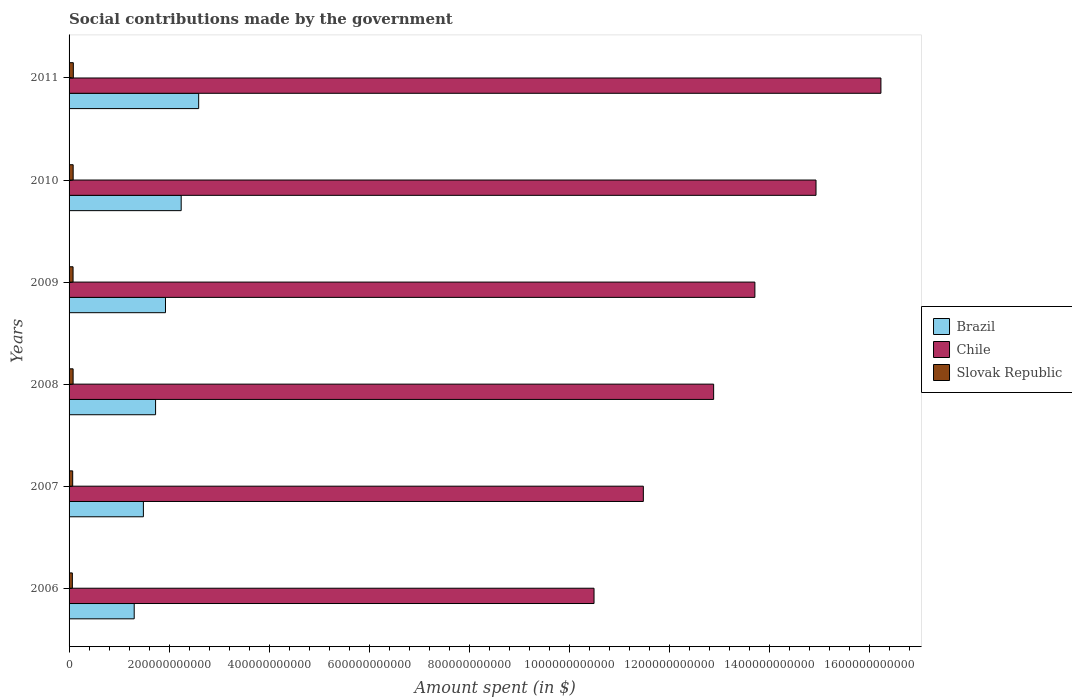How many different coloured bars are there?
Give a very brief answer. 3. Are the number of bars on each tick of the Y-axis equal?
Your answer should be very brief. Yes. How many bars are there on the 2nd tick from the top?
Give a very brief answer. 3. How many bars are there on the 4th tick from the bottom?
Provide a succinct answer. 3. What is the label of the 3rd group of bars from the top?
Keep it short and to the point. 2009. In how many cases, is the number of bars for a given year not equal to the number of legend labels?
Keep it short and to the point. 0. What is the amount spent on social contributions in Slovak Republic in 2008?
Your answer should be compact. 8.07e+09. Across all years, what is the maximum amount spent on social contributions in Slovak Republic?
Provide a succinct answer. 8.51e+09. Across all years, what is the minimum amount spent on social contributions in Chile?
Your answer should be compact. 1.05e+12. In which year was the amount spent on social contributions in Slovak Republic maximum?
Offer a very short reply. 2011. What is the total amount spent on social contributions in Chile in the graph?
Your answer should be compact. 7.98e+12. What is the difference between the amount spent on social contributions in Slovak Republic in 2006 and that in 2007?
Ensure brevity in your answer.  -6.41e+08. What is the difference between the amount spent on social contributions in Slovak Republic in 2006 and the amount spent on social contributions in Chile in 2009?
Keep it short and to the point. -1.37e+12. What is the average amount spent on social contributions in Chile per year?
Provide a succinct answer. 1.33e+12. In the year 2006, what is the difference between the amount spent on social contributions in Brazil and amount spent on social contributions in Slovak Republic?
Keep it short and to the point. 1.24e+11. In how many years, is the amount spent on social contributions in Chile greater than 480000000000 $?
Your answer should be compact. 6. What is the ratio of the amount spent on social contributions in Chile in 2006 to that in 2009?
Your response must be concise. 0.77. Is the amount spent on social contributions in Chile in 2006 less than that in 2011?
Provide a succinct answer. Yes. Is the difference between the amount spent on social contributions in Brazil in 2007 and 2008 greater than the difference between the amount spent on social contributions in Slovak Republic in 2007 and 2008?
Provide a succinct answer. No. What is the difference between the highest and the second highest amount spent on social contributions in Slovak Republic?
Ensure brevity in your answer.  3.31e+08. What is the difference between the highest and the lowest amount spent on social contributions in Slovak Republic?
Provide a short and direct response. 1.93e+09. What does the 1st bar from the top in 2007 represents?
Your response must be concise. Slovak Republic. What does the 1st bar from the bottom in 2009 represents?
Provide a short and direct response. Brazil. What is the difference between two consecutive major ticks on the X-axis?
Provide a succinct answer. 2.00e+11. Does the graph contain any zero values?
Your answer should be compact. No. Where does the legend appear in the graph?
Give a very brief answer. Center right. What is the title of the graph?
Ensure brevity in your answer.  Social contributions made by the government. Does "Pacific island small states" appear as one of the legend labels in the graph?
Your answer should be compact. No. What is the label or title of the X-axis?
Provide a succinct answer. Amount spent (in $). What is the Amount spent (in $) in Brazil in 2006?
Ensure brevity in your answer.  1.30e+11. What is the Amount spent (in $) in Chile in 2006?
Provide a succinct answer. 1.05e+12. What is the Amount spent (in $) of Slovak Republic in 2006?
Ensure brevity in your answer.  6.59e+09. What is the Amount spent (in $) of Brazil in 2007?
Ensure brevity in your answer.  1.49e+11. What is the Amount spent (in $) of Chile in 2007?
Provide a short and direct response. 1.15e+12. What is the Amount spent (in $) in Slovak Republic in 2007?
Make the answer very short. 7.23e+09. What is the Amount spent (in $) in Brazil in 2008?
Offer a very short reply. 1.73e+11. What is the Amount spent (in $) in Chile in 2008?
Your answer should be very brief. 1.29e+12. What is the Amount spent (in $) of Slovak Republic in 2008?
Keep it short and to the point. 8.07e+09. What is the Amount spent (in $) of Brazil in 2009?
Offer a very short reply. 1.93e+11. What is the Amount spent (in $) in Chile in 2009?
Make the answer very short. 1.37e+12. What is the Amount spent (in $) of Slovak Republic in 2009?
Provide a succinct answer. 7.99e+09. What is the Amount spent (in $) of Brazil in 2010?
Make the answer very short. 2.24e+11. What is the Amount spent (in $) in Chile in 2010?
Give a very brief answer. 1.49e+12. What is the Amount spent (in $) in Slovak Republic in 2010?
Provide a short and direct response. 8.18e+09. What is the Amount spent (in $) of Brazil in 2011?
Your answer should be very brief. 2.59e+11. What is the Amount spent (in $) of Chile in 2011?
Provide a short and direct response. 1.62e+12. What is the Amount spent (in $) in Slovak Republic in 2011?
Your response must be concise. 8.51e+09. Across all years, what is the maximum Amount spent (in $) of Brazil?
Offer a terse response. 2.59e+11. Across all years, what is the maximum Amount spent (in $) of Chile?
Keep it short and to the point. 1.62e+12. Across all years, what is the maximum Amount spent (in $) in Slovak Republic?
Give a very brief answer. 8.51e+09. Across all years, what is the minimum Amount spent (in $) of Brazil?
Give a very brief answer. 1.30e+11. Across all years, what is the minimum Amount spent (in $) in Chile?
Your answer should be very brief. 1.05e+12. Across all years, what is the minimum Amount spent (in $) of Slovak Republic?
Your answer should be very brief. 6.59e+09. What is the total Amount spent (in $) in Brazil in the graph?
Provide a succinct answer. 1.13e+12. What is the total Amount spent (in $) in Chile in the graph?
Your response must be concise. 7.98e+12. What is the total Amount spent (in $) of Slovak Republic in the graph?
Your response must be concise. 4.66e+1. What is the difference between the Amount spent (in $) of Brazil in 2006 and that in 2007?
Keep it short and to the point. -1.84e+1. What is the difference between the Amount spent (in $) of Chile in 2006 and that in 2007?
Offer a terse response. -9.86e+1. What is the difference between the Amount spent (in $) of Slovak Republic in 2006 and that in 2007?
Provide a short and direct response. -6.41e+08. What is the difference between the Amount spent (in $) of Brazil in 2006 and that in 2008?
Offer a terse response. -4.28e+1. What is the difference between the Amount spent (in $) in Chile in 2006 and that in 2008?
Keep it short and to the point. -2.39e+11. What is the difference between the Amount spent (in $) in Slovak Republic in 2006 and that in 2008?
Give a very brief answer. -1.48e+09. What is the difference between the Amount spent (in $) in Brazil in 2006 and that in 2009?
Offer a terse response. -6.26e+1. What is the difference between the Amount spent (in $) in Chile in 2006 and that in 2009?
Give a very brief answer. -3.22e+11. What is the difference between the Amount spent (in $) of Slovak Republic in 2006 and that in 2009?
Make the answer very short. -1.41e+09. What is the difference between the Amount spent (in $) of Brazil in 2006 and that in 2010?
Offer a terse response. -9.40e+1. What is the difference between the Amount spent (in $) in Chile in 2006 and that in 2010?
Your response must be concise. -4.44e+11. What is the difference between the Amount spent (in $) of Slovak Republic in 2006 and that in 2010?
Your response must be concise. -1.60e+09. What is the difference between the Amount spent (in $) in Brazil in 2006 and that in 2011?
Make the answer very short. -1.29e+11. What is the difference between the Amount spent (in $) of Chile in 2006 and that in 2011?
Make the answer very short. -5.74e+11. What is the difference between the Amount spent (in $) in Slovak Republic in 2006 and that in 2011?
Ensure brevity in your answer.  -1.93e+09. What is the difference between the Amount spent (in $) of Brazil in 2007 and that in 2008?
Provide a short and direct response. -2.44e+1. What is the difference between the Amount spent (in $) of Chile in 2007 and that in 2008?
Give a very brief answer. -1.41e+11. What is the difference between the Amount spent (in $) in Slovak Republic in 2007 and that in 2008?
Provide a short and direct response. -8.43e+08. What is the difference between the Amount spent (in $) of Brazil in 2007 and that in 2009?
Provide a succinct answer. -4.42e+1. What is the difference between the Amount spent (in $) in Chile in 2007 and that in 2009?
Ensure brevity in your answer.  -2.23e+11. What is the difference between the Amount spent (in $) in Slovak Republic in 2007 and that in 2009?
Your response must be concise. -7.65e+08. What is the difference between the Amount spent (in $) in Brazil in 2007 and that in 2010?
Ensure brevity in your answer.  -7.56e+1. What is the difference between the Amount spent (in $) of Chile in 2007 and that in 2010?
Offer a very short reply. -3.45e+11. What is the difference between the Amount spent (in $) in Slovak Republic in 2007 and that in 2010?
Ensure brevity in your answer.  -9.55e+08. What is the difference between the Amount spent (in $) of Brazil in 2007 and that in 2011?
Provide a short and direct response. -1.11e+11. What is the difference between the Amount spent (in $) of Chile in 2007 and that in 2011?
Give a very brief answer. -4.75e+11. What is the difference between the Amount spent (in $) of Slovak Republic in 2007 and that in 2011?
Your answer should be very brief. -1.29e+09. What is the difference between the Amount spent (in $) in Brazil in 2008 and that in 2009?
Offer a terse response. -1.98e+1. What is the difference between the Amount spent (in $) in Chile in 2008 and that in 2009?
Offer a terse response. -8.25e+1. What is the difference between the Amount spent (in $) of Slovak Republic in 2008 and that in 2009?
Provide a succinct answer. 7.78e+07. What is the difference between the Amount spent (in $) in Brazil in 2008 and that in 2010?
Keep it short and to the point. -5.12e+1. What is the difference between the Amount spent (in $) of Chile in 2008 and that in 2010?
Ensure brevity in your answer.  -2.05e+11. What is the difference between the Amount spent (in $) of Slovak Republic in 2008 and that in 2010?
Provide a succinct answer. -1.13e+08. What is the difference between the Amount spent (in $) in Brazil in 2008 and that in 2011?
Keep it short and to the point. -8.62e+1. What is the difference between the Amount spent (in $) in Chile in 2008 and that in 2011?
Provide a short and direct response. -3.35e+11. What is the difference between the Amount spent (in $) in Slovak Republic in 2008 and that in 2011?
Keep it short and to the point. -4.43e+08. What is the difference between the Amount spent (in $) in Brazil in 2009 and that in 2010?
Give a very brief answer. -3.14e+1. What is the difference between the Amount spent (in $) of Chile in 2009 and that in 2010?
Make the answer very short. -1.22e+11. What is the difference between the Amount spent (in $) of Slovak Republic in 2009 and that in 2010?
Your answer should be compact. -1.91e+08. What is the difference between the Amount spent (in $) of Brazil in 2009 and that in 2011?
Your response must be concise. -6.64e+1. What is the difference between the Amount spent (in $) in Chile in 2009 and that in 2011?
Your answer should be compact. -2.52e+11. What is the difference between the Amount spent (in $) of Slovak Republic in 2009 and that in 2011?
Your answer should be compact. -5.21e+08. What is the difference between the Amount spent (in $) of Brazil in 2010 and that in 2011?
Your answer should be very brief. -3.50e+1. What is the difference between the Amount spent (in $) in Chile in 2010 and that in 2011?
Make the answer very short. -1.30e+11. What is the difference between the Amount spent (in $) in Slovak Republic in 2010 and that in 2011?
Give a very brief answer. -3.31e+08. What is the difference between the Amount spent (in $) in Brazil in 2006 and the Amount spent (in $) in Chile in 2007?
Ensure brevity in your answer.  -1.02e+12. What is the difference between the Amount spent (in $) in Brazil in 2006 and the Amount spent (in $) in Slovak Republic in 2007?
Provide a short and direct response. 1.23e+11. What is the difference between the Amount spent (in $) in Chile in 2006 and the Amount spent (in $) in Slovak Republic in 2007?
Your answer should be very brief. 1.04e+12. What is the difference between the Amount spent (in $) of Brazil in 2006 and the Amount spent (in $) of Chile in 2008?
Your answer should be compact. -1.16e+12. What is the difference between the Amount spent (in $) of Brazil in 2006 and the Amount spent (in $) of Slovak Republic in 2008?
Offer a very short reply. 1.22e+11. What is the difference between the Amount spent (in $) in Chile in 2006 and the Amount spent (in $) in Slovak Republic in 2008?
Provide a succinct answer. 1.04e+12. What is the difference between the Amount spent (in $) of Brazil in 2006 and the Amount spent (in $) of Chile in 2009?
Give a very brief answer. -1.24e+12. What is the difference between the Amount spent (in $) of Brazil in 2006 and the Amount spent (in $) of Slovak Republic in 2009?
Give a very brief answer. 1.22e+11. What is the difference between the Amount spent (in $) in Chile in 2006 and the Amount spent (in $) in Slovak Republic in 2009?
Ensure brevity in your answer.  1.04e+12. What is the difference between the Amount spent (in $) in Brazil in 2006 and the Amount spent (in $) in Chile in 2010?
Provide a succinct answer. -1.36e+12. What is the difference between the Amount spent (in $) of Brazil in 2006 and the Amount spent (in $) of Slovak Republic in 2010?
Provide a succinct answer. 1.22e+11. What is the difference between the Amount spent (in $) of Chile in 2006 and the Amount spent (in $) of Slovak Republic in 2010?
Offer a very short reply. 1.04e+12. What is the difference between the Amount spent (in $) in Brazil in 2006 and the Amount spent (in $) in Chile in 2011?
Keep it short and to the point. -1.49e+12. What is the difference between the Amount spent (in $) in Brazil in 2006 and the Amount spent (in $) in Slovak Republic in 2011?
Give a very brief answer. 1.22e+11. What is the difference between the Amount spent (in $) in Chile in 2006 and the Amount spent (in $) in Slovak Republic in 2011?
Your response must be concise. 1.04e+12. What is the difference between the Amount spent (in $) in Brazil in 2007 and the Amount spent (in $) in Chile in 2008?
Offer a terse response. -1.14e+12. What is the difference between the Amount spent (in $) of Brazil in 2007 and the Amount spent (in $) of Slovak Republic in 2008?
Your response must be concise. 1.41e+11. What is the difference between the Amount spent (in $) of Chile in 2007 and the Amount spent (in $) of Slovak Republic in 2008?
Provide a succinct answer. 1.14e+12. What is the difference between the Amount spent (in $) in Brazil in 2007 and the Amount spent (in $) in Chile in 2009?
Your answer should be compact. -1.22e+12. What is the difference between the Amount spent (in $) in Brazil in 2007 and the Amount spent (in $) in Slovak Republic in 2009?
Give a very brief answer. 1.41e+11. What is the difference between the Amount spent (in $) in Chile in 2007 and the Amount spent (in $) in Slovak Republic in 2009?
Make the answer very short. 1.14e+12. What is the difference between the Amount spent (in $) in Brazil in 2007 and the Amount spent (in $) in Chile in 2010?
Your answer should be compact. -1.35e+12. What is the difference between the Amount spent (in $) in Brazil in 2007 and the Amount spent (in $) in Slovak Republic in 2010?
Offer a very short reply. 1.40e+11. What is the difference between the Amount spent (in $) of Chile in 2007 and the Amount spent (in $) of Slovak Republic in 2010?
Keep it short and to the point. 1.14e+12. What is the difference between the Amount spent (in $) of Brazil in 2007 and the Amount spent (in $) of Chile in 2011?
Provide a succinct answer. -1.48e+12. What is the difference between the Amount spent (in $) in Brazil in 2007 and the Amount spent (in $) in Slovak Republic in 2011?
Ensure brevity in your answer.  1.40e+11. What is the difference between the Amount spent (in $) in Chile in 2007 and the Amount spent (in $) in Slovak Republic in 2011?
Offer a terse response. 1.14e+12. What is the difference between the Amount spent (in $) in Brazil in 2008 and the Amount spent (in $) in Chile in 2009?
Make the answer very short. -1.20e+12. What is the difference between the Amount spent (in $) in Brazil in 2008 and the Amount spent (in $) in Slovak Republic in 2009?
Provide a succinct answer. 1.65e+11. What is the difference between the Amount spent (in $) of Chile in 2008 and the Amount spent (in $) of Slovak Republic in 2009?
Your answer should be very brief. 1.28e+12. What is the difference between the Amount spent (in $) of Brazil in 2008 and the Amount spent (in $) of Chile in 2010?
Offer a very short reply. -1.32e+12. What is the difference between the Amount spent (in $) in Brazil in 2008 and the Amount spent (in $) in Slovak Republic in 2010?
Keep it short and to the point. 1.65e+11. What is the difference between the Amount spent (in $) in Chile in 2008 and the Amount spent (in $) in Slovak Republic in 2010?
Your response must be concise. 1.28e+12. What is the difference between the Amount spent (in $) in Brazil in 2008 and the Amount spent (in $) in Chile in 2011?
Offer a terse response. -1.45e+12. What is the difference between the Amount spent (in $) in Brazil in 2008 and the Amount spent (in $) in Slovak Republic in 2011?
Your response must be concise. 1.65e+11. What is the difference between the Amount spent (in $) in Chile in 2008 and the Amount spent (in $) in Slovak Republic in 2011?
Your response must be concise. 1.28e+12. What is the difference between the Amount spent (in $) of Brazil in 2009 and the Amount spent (in $) of Chile in 2010?
Offer a terse response. -1.30e+12. What is the difference between the Amount spent (in $) of Brazil in 2009 and the Amount spent (in $) of Slovak Republic in 2010?
Offer a terse response. 1.85e+11. What is the difference between the Amount spent (in $) of Chile in 2009 and the Amount spent (in $) of Slovak Republic in 2010?
Keep it short and to the point. 1.36e+12. What is the difference between the Amount spent (in $) of Brazil in 2009 and the Amount spent (in $) of Chile in 2011?
Offer a terse response. -1.43e+12. What is the difference between the Amount spent (in $) of Brazil in 2009 and the Amount spent (in $) of Slovak Republic in 2011?
Give a very brief answer. 1.84e+11. What is the difference between the Amount spent (in $) of Chile in 2009 and the Amount spent (in $) of Slovak Republic in 2011?
Your response must be concise. 1.36e+12. What is the difference between the Amount spent (in $) of Brazil in 2010 and the Amount spent (in $) of Chile in 2011?
Your response must be concise. -1.40e+12. What is the difference between the Amount spent (in $) in Brazil in 2010 and the Amount spent (in $) in Slovak Republic in 2011?
Your answer should be very brief. 2.16e+11. What is the difference between the Amount spent (in $) in Chile in 2010 and the Amount spent (in $) in Slovak Republic in 2011?
Give a very brief answer. 1.49e+12. What is the average Amount spent (in $) in Brazil per year?
Make the answer very short. 1.88e+11. What is the average Amount spent (in $) of Chile per year?
Your answer should be compact. 1.33e+12. What is the average Amount spent (in $) in Slovak Republic per year?
Make the answer very short. 7.76e+09. In the year 2006, what is the difference between the Amount spent (in $) in Brazil and Amount spent (in $) in Chile?
Make the answer very short. -9.20e+11. In the year 2006, what is the difference between the Amount spent (in $) of Brazil and Amount spent (in $) of Slovak Republic?
Make the answer very short. 1.24e+11. In the year 2006, what is the difference between the Amount spent (in $) of Chile and Amount spent (in $) of Slovak Republic?
Offer a terse response. 1.04e+12. In the year 2007, what is the difference between the Amount spent (in $) in Brazil and Amount spent (in $) in Chile?
Provide a succinct answer. -1.00e+12. In the year 2007, what is the difference between the Amount spent (in $) of Brazil and Amount spent (in $) of Slovak Republic?
Your response must be concise. 1.41e+11. In the year 2007, what is the difference between the Amount spent (in $) of Chile and Amount spent (in $) of Slovak Republic?
Your answer should be very brief. 1.14e+12. In the year 2008, what is the difference between the Amount spent (in $) in Brazil and Amount spent (in $) in Chile?
Give a very brief answer. -1.12e+12. In the year 2008, what is the difference between the Amount spent (in $) of Brazil and Amount spent (in $) of Slovak Republic?
Provide a short and direct response. 1.65e+11. In the year 2008, what is the difference between the Amount spent (in $) of Chile and Amount spent (in $) of Slovak Republic?
Your response must be concise. 1.28e+12. In the year 2009, what is the difference between the Amount spent (in $) in Brazil and Amount spent (in $) in Chile?
Provide a succinct answer. -1.18e+12. In the year 2009, what is the difference between the Amount spent (in $) in Brazil and Amount spent (in $) in Slovak Republic?
Your response must be concise. 1.85e+11. In the year 2009, what is the difference between the Amount spent (in $) in Chile and Amount spent (in $) in Slovak Republic?
Your answer should be very brief. 1.36e+12. In the year 2010, what is the difference between the Amount spent (in $) of Brazil and Amount spent (in $) of Chile?
Ensure brevity in your answer.  -1.27e+12. In the year 2010, what is the difference between the Amount spent (in $) in Brazil and Amount spent (in $) in Slovak Republic?
Provide a succinct answer. 2.16e+11. In the year 2010, what is the difference between the Amount spent (in $) of Chile and Amount spent (in $) of Slovak Republic?
Keep it short and to the point. 1.49e+12. In the year 2011, what is the difference between the Amount spent (in $) of Brazil and Amount spent (in $) of Chile?
Offer a very short reply. -1.36e+12. In the year 2011, what is the difference between the Amount spent (in $) in Brazil and Amount spent (in $) in Slovak Republic?
Ensure brevity in your answer.  2.51e+11. In the year 2011, what is the difference between the Amount spent (in $) in Chile and Amount spent (in $) in Slovak Republic?
Keep it short and to the point. 1.62e+12. What is the ratio of the Amount spent (in $) in Brazil in 2006 to that in 2007?
Your answer should be compact. 0.88. What is the ratio of the Amount spent (in $) in Chile in 2006 to that in 2007?
Ensure brevity in your answer.  0.91. What is the ratio of the Amount spent (in $) in Slovak Republic in 2006 to that in 2007?
Ensure brevity in your answer.  0.91. What is the ratio of the Amount spent (in $) in Brazil in 2006 to that in 2008?
Your answer should be very brief. 0.75. What is the ratio of the Amount spent (in $) in Chile in 2006 to that in 2008?
Your answer should be very brief. 0.81. What is the ratio of the Amount spent (in $) of Slovak Republic in 2006 to that in 2008?
Provide a short and direct response. 0.82. What is the ratio of the Amount spent (in $) in Brazil in 2006 to that in 2009?
Your response must be concise. 0.68. What is the ratio of the Amount spent (in $) in Chile in 2006 to that in 2009?
Offer a terse response. 0.77. What is the ratio of the Amount spent (in $) of Slovak Republic in 2006 to that in 2009?
Give a very brief answer. 0.82. What is the ratio of the Amount spent (in $) of Brazil in 2006 to that in 2010?
Offer a very short reply. 0.58. What is the ratio of the Amount spent (in $) of Chile in 2006 to that in 2010?
Offer a very short reply. 0.7. What is the ratio of the Amount spent (in $) of Slovak Republic in 2006 to that in 2010?
Your response must be concise. 0.8. What is the ratio of the Amount spent (in $) in Brazil in 2006 to that in 2011?
Make the answer very short. 0.5. What is the ratio of the Amount spent (in $) in Chile in 2006 to that in 2011?
Make the answer very short. 0.65. What is the ratio of the Amount spent (in $) in Slovak Republic in 2006 to that in 2011?
Ensure brevity in your answer.  0.77. What is the ratio of the Amount spent (in $) of Brazil in 2007 to that in 2008?
Provide a succinct answer. 0.86. What is the ratio of the Amount spent (in $) in Chile in 2007 to that in 2008?
Give a very brief answer. 0.89. What is the ratio of the Amount spent (in $) of Slovak Republic in 2007 to that in 2008?
Your response must be concise. 0.9. What is the ratio of the Amount spent (in $) in Brazil in 2007 to that in 2009?
Provide a succinct answer. 0.77. What is the ratio of the Amount spent (in $) of Chile in 2007 to that in 2009?
Your answer should be compact. 0.84. What is the ratio of the Amount spent (in $) of Slovak Republic in 2007 to that in 2009?
Keep it short and to the point. 0.9. What is the ratio of the Amount spent (in $) of Brazil in 2007 to that in 2010?
Provide a succinct answer. 0.66. What is the ratio of the Amount spent (in $) of Chile in 2007 to that in 2010?
Offer a terse response. 0.77. What is the ratio of the Amount spent (in $) of Slovak Republic in 2007 to that in 2010?
Give a very brief answer. 0.88. What is the ratio of the Amount spent (in $) of Brazil in 2007 to that in 2011?
Ensure brevity in your answer.  0.57. What is the ratio of the Amount spent (in $) in Chile in 2007 to that in 2011?
Give a very brief answer. 0.71. What is the ratio of the Amount spent (in $) in Slovak Republic in 2007 to that in 2011?
Your answer should be very brief. 0.85. What is the ratio of the Amount spent (in $) in Brazil in 2008 to that in 2009?
Ensure brevity in your answer.  0.9. What is the ratio of the Amount spent (in $) of Chile in 2008 to that in 2009?
Keep it short and to the point. 0.94. What is the ratio of the Amount spent (in $) in Slovak Republic in 2008 to that in 2009?
Keep it short and to the point. 1.01. What is the ratio of the Amount spent (in $) in Brazil in 2008 to that in 2010?
Make the answer very short. 0.77. What is the ratio of the Amount spent (in $) in Chile in 2008 to that in 2010?
Provide a succinct answer. 0.86. What is the ratio of the Amount spent (in $) of Slovak Republic in 2008 to that in 2010?
Your response must be concise. 0.99. What is the ratio of the Amount spent (in $) in Brazil in 2008 to that in 2011?
Offer a terse response. 0.67. What is the ratio of the Amount spent (in $) of Chile in 2008 to that in 2011?
Offer a terse response. 0.79. What is the ratio of the Amount spent (in $) in Slovak Republic in 2008 to that in 2011?
Offer a very short reply. 0.95. What is the ratio of the Amount spent (in $) in Brazil in 2009 to that in 2010?
Your answer should be very brief. 0.86. What is the ratio of the Amount spent (in $) in Chile in 2009 to that in 2010?
Give a very brief answer. 0.92. What is the ratio of the Amount spent (in $) in Slovak Republic in 2009 to that in 2010?
Your response must be concise. 0.98. What is the ratio of the Amount spent (in $) in Brazil in 2009 to that in 2011?
Make the answer very short. 0.74. What is the ratio of the Amount spent (in $) of Chile in 2009 to that in 2011?
Keep it short and to the point. 0.84. What is the ratio of the Amount spent (in $) of Slovak Republic in 2009 to that in 2011?
Make the answer very short. 0.94. What is the ratio of the Amount spent (in $) of Brazil in 2010 to that in 2011?
Your answer should be compact. 0.86. What is the ratio of the Amount spent (in $) of Chile in 2010 to that in 2011?
Your response must be concise. 0.92. What is the ratio of the Amount spent (in $) in Slovak Republic in 2010 to that in 2011?
Provide a succinct answer. 0.96. What is the difference between the highest and the second highest Amount spent (in $) in Brazil?
Make the answer very short. 3.50e+1. What is the difference between the highest and the second highest Amount spent (in $) of Chile?
Ensure brevity in your answer.  1.30e+11. What is the difference between the highest and the second highest Amount spent (in $) in Slovak Republic?
Offer a terse response. 3.31e+08. What is the difference between the highest and the lowest Amount spent (in $) in Brazil?
Give a very brief answer. 1.29e+11. What is the difference between the highest and the lowest Amount spent (in $) of Chile?
Offer a terse response. 5.74e+11. What is the difference between the highest and the lowest Amount spent (in $) in Slovak Republic?
Offer a terse response. 1.93e+09. 